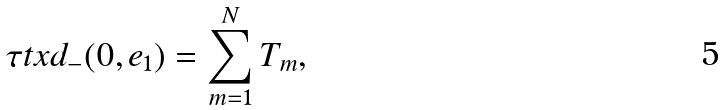Convert formula to latex. <formula><loc_0><loc_0><loc_500><loc_500>\tau t x { d _ { - } } ( 0 , e _ { 1 } ) = \sum _ { m = 1 } ^ { N } T _ { m } ,</formula> 